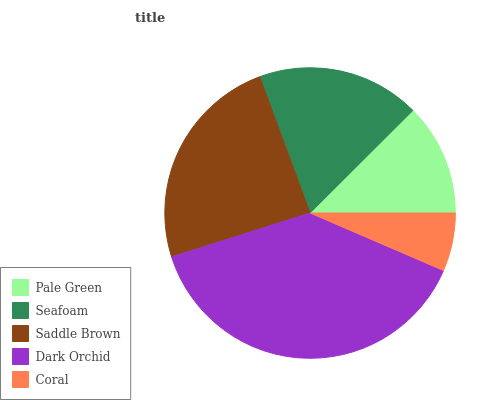Is Coral the minimum?
Answer yes or no. Yes. Is Dark Orchid the maximum?
Answer yes or no. Yes. Is Seafoam the minimum?
Answer yes or no. No. Is Seafoam the maximum?
Answer yes or no. No. Is Seafoam greater than Pale Green?
Answer yes or no. Yes. Is Pale Green less than Seafoam?
Answer yes or no. Yes. Is Pale Green greater than Seafoam?
Answer yes or no. No. Is Seafoam less than Pale Green?
Answer yes or no. No. Is Seafoam the high median?
Answer yes or no. Yes. Is Seafoam the low median?
Answer yes or no. Yes. Is Dark Orchid the high median?
Answer yes or no. No. Is Dark Orchid the low median?
Answer yes or no. No. 